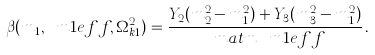<formula> <loc_0><loc_0><loc_500><loc_500>\beta ( m _ { 1 } , \ m 1 e f f , \Omega _ { k 1 } ^ { 2 } ) = \frac { Y _ { 2 } ( m _ { 2 } ^ { 2 } - m _ { 1 } ^ { 2 } ) + Y _ { 3 } ( m _ { 3 } ^ { 2 } - m _ { 1 } ^ { 2 } ) } { \ m a t m \, \ m 1 e f f } \, .</formula> 